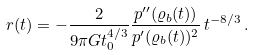<formula> <loc_0><loc_0><loc_500><loc_500>r ( t ) = - \frac { 2 } { 9 \pi G t _ { 0 } ^ { 4 / 3 } } \frac { p ^ { \prime \prime } ( \varrho _ { b } ( t ) ) } { p ^ { \prime } ( \varrho _ { b } ( t ) ) ^ { 2 } } \, t ^ { - 8 / 3 } \, .</formula> 